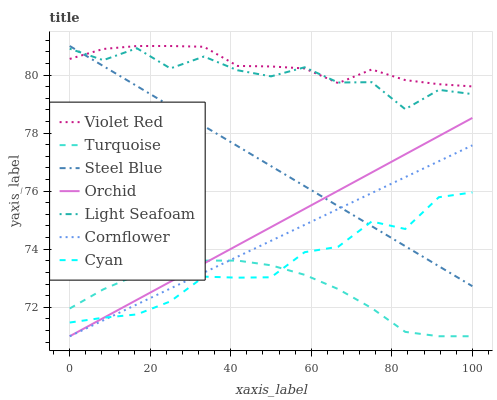Does Turquoise have the minimum area under the curve?
Answer yes or no. Yes. Does Violet Red have the maximum area under the curve?
Answer yes or no. Yes. Does Violet Red have the minimum area under the curve?
Answer yes or no. No. Does Turquoise have the maximum area under the curve?
Answer yes or no. No. Is Cornflower the smoothest?
Answer yes or no. Yes. Is Light Seafoam the roughest?
Answer yes or no. Yes. Is Violet Red the smoothest?
Answer yes or no. No. Is Violet Red the roughest?
Answer yes or no. No. Does Cornflower have the lowest value?
Answer yes or no. Yes. Does Violet Red have the lowest value?
Answer yes or no. No. Does Steel Blue have the highest value?
Answer yes or no. Yes. Does Turquoise have the highest value?
Answer yes or no. No. Is Orchid less than Violet Red?
Answer yes or no. Yes. Is Violet Red greater than Turquoise?
Answer yes or no. Yes. Does Cyan intersect Orchid?
Answer yes or no. Yes. Is Cyan less than Orchid?
Answer yes or no. No. Is Cyan greater than Orchid?
Answer yes or no. No. Does Orchid intersect Violet Red?
Answer yes or no. No. 